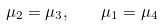Convert formula to latex. <formula><loc_0><loc_0><loc_500><loc_500>\mu _ { 2 } = \mu _ { 3 } , \quad \mu _ { 1 } = \mu _ { 4 }</formula> 